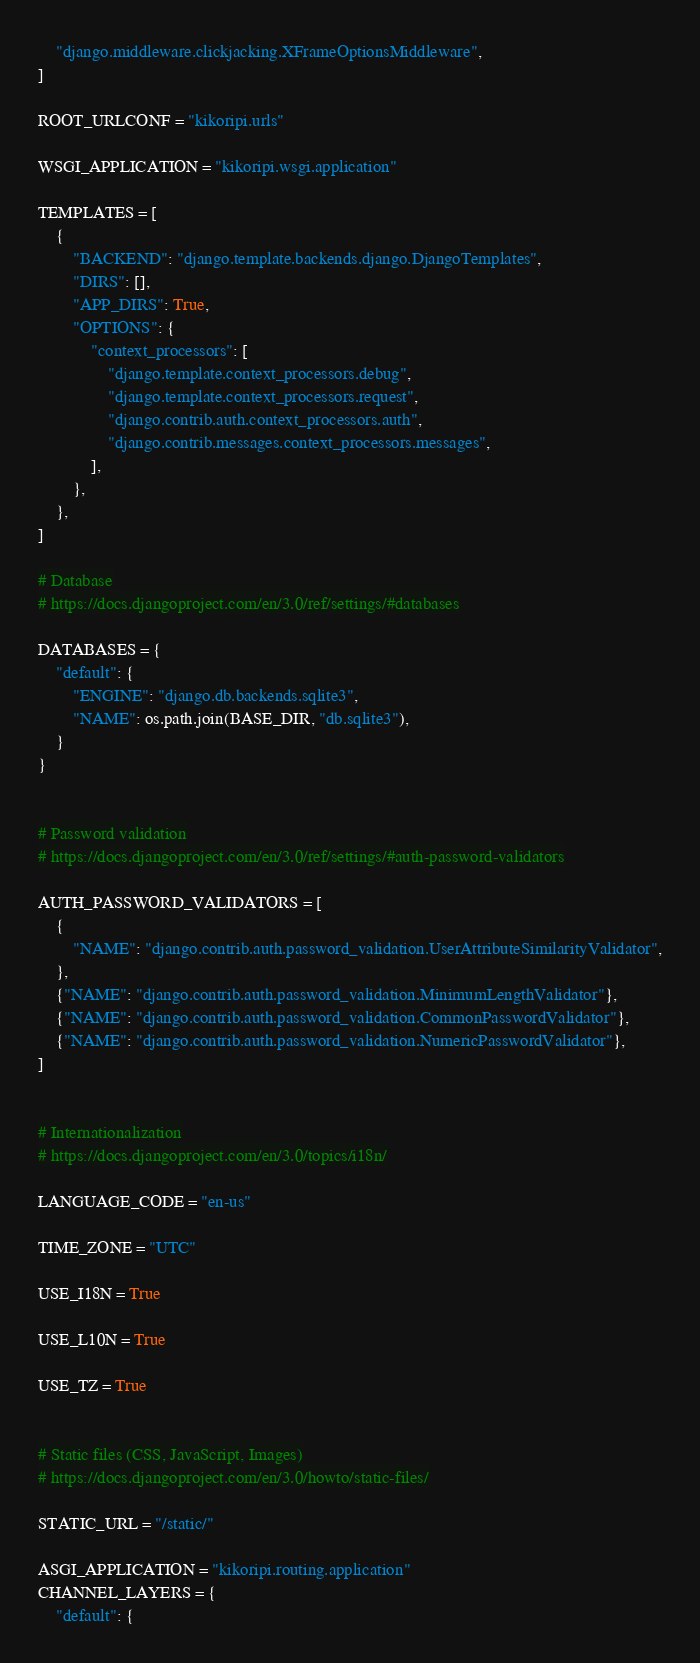Convert code to text. <code><loc_0><loc_0><loc_500><loc_500><_Python_>    "django.middleware.clickjacking.XFrameOptionsMiddleware",
]

ROOT_URLCONF = "kikoripi.urls"

WSGI_APPLICATION = "kikoripi.wsgi.application"

TEMPLATES = [
    {
        "BACKEND": "django.template.backends.django.DjangoTemplates",
        "DIRS": [],
        "APP_DIRS": True,
        "OPTIONS": {
            "context_processors": [
                "django.template.context_processors.debug",
                "django.template.context_processors.request",
                "django.contrib.auth.context_processors.auth",
                "django.contrib.messages.context_processors.messages",
            ],
        },
    },
]

# Database
# https://docs.djangoproject.com/en/3.0/ref/settings/#databases

DATABASES = {
    "default": {
        "ENGINE": "django.db.backends.sqlite3",
        "NAME": os.path.join(BASE_DIR, "db.sqlite3"),
    }
}


# Password validation
# https://docs.djangoproject.com/en/3.0/ref/settings/#auth-password-validators

AUTH_PASSWORD_VALIDATORS = [
    {
        "NAME": "django.contrib.auth.password_validation.UserAttributeSimilarityValidator",
    },
    {"NAME": "django.contrib.auth.password_validation.MinimumLengthValidator"},
    {"NAME": "django.contrib.auth.password_validation.CommonPasswordValidator"},
    {"NAME": "django.contrib.auth.password_validation.NumericPasswordValidator"},
]


# Internationalization
# https://docs.djangoproject.com/en/3.0/topics/i18n/

LANGUAGE_CODE = "en-us"

TIME_ZONE = "UTC"

USE_I18N = True

USE_L10N = True

USE_TZ = True


# Static files (CSS, JavaScript, Images)
# https://docs.djangoproject.com/en/3.0/howto/static-files/

STATIC_URL = "/static/"

ASGI_APPLICATION = "kikoripi.routing.application"
CHANNEL_LAYERS = {
    "default": {</code> 